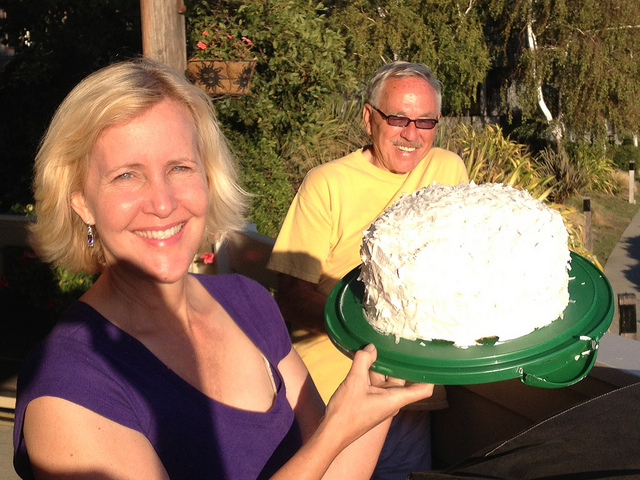How many people are in the picture? 2 